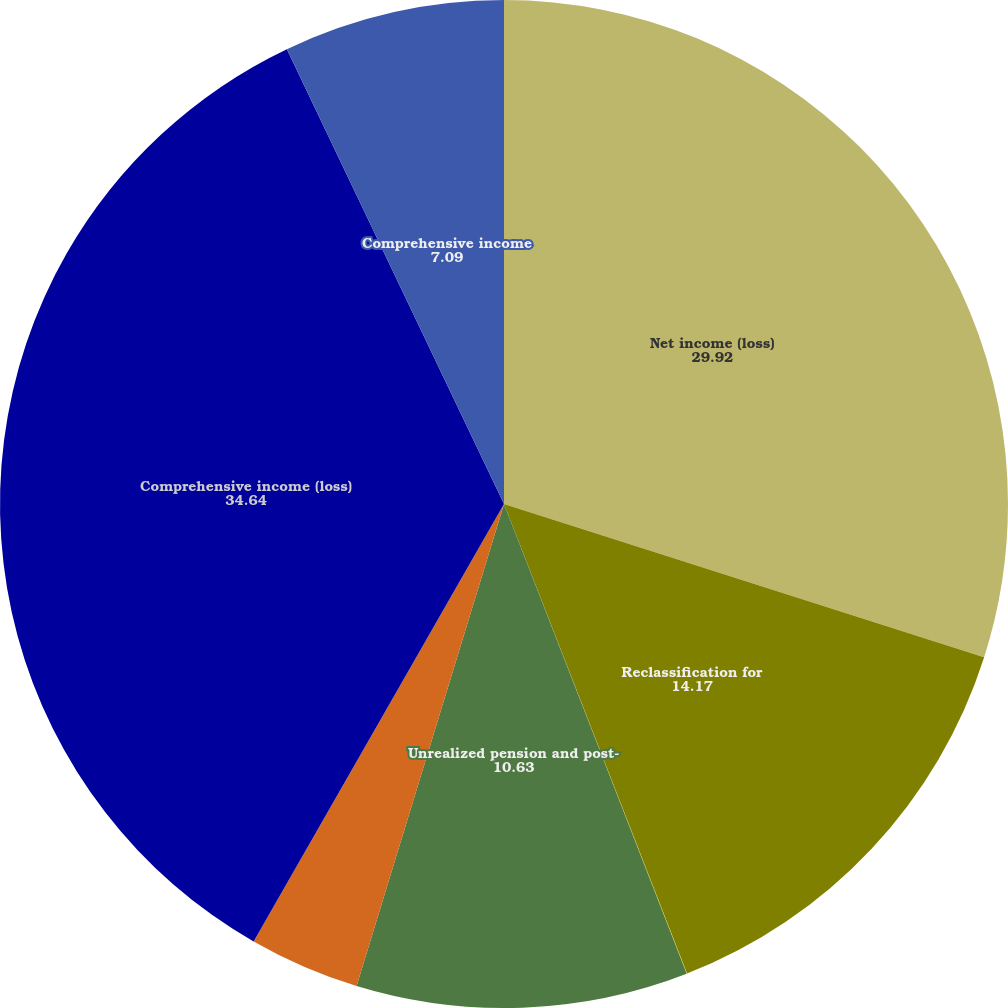Convert chart. <chart><loc_0><loc_0><loc_500><loc_500><pie_chart><fcel>Net income (loss)<fcel>Reclassification for<fcel>Unrealized gains on<fcel>Unrealized pension and post-<fcel>Reclassification for pension<fcel>Comprehensive income (loss)<fcel>Comprehensive income<nl><fcel>29.92%<fcel>14.17%<fcel>0.01%<fcel>10.63%<fcel>3.55%<fcel>34.64%<fcel>7.09%<nl></chart> 